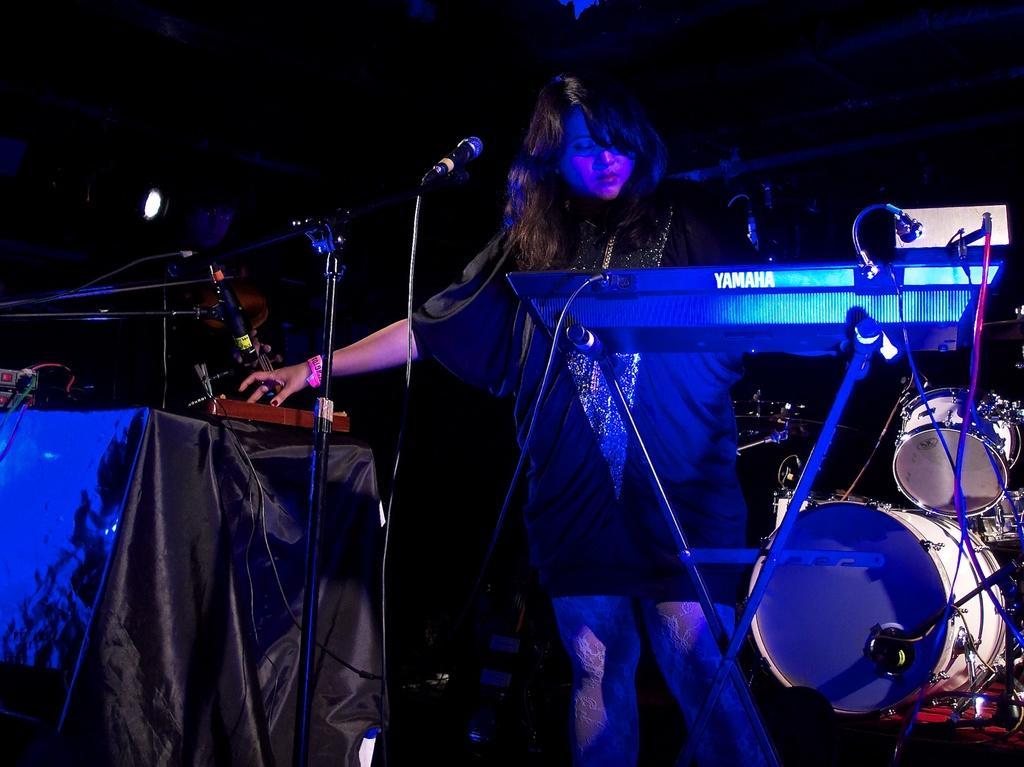Describe this image in one or two sentences. In this picture we can see musical instruments, mics, cloth, devices, light and a woman standing and in the background it is dark. 